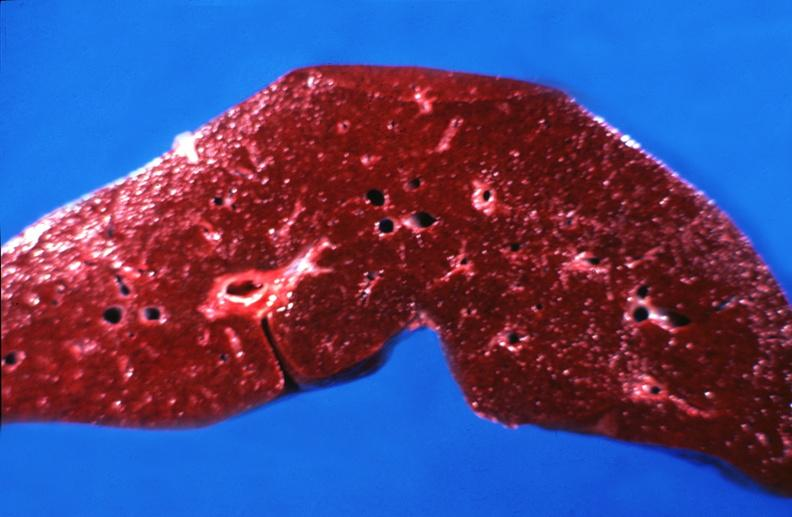what does this image show?
Answer the question using a single word or phrase. Hemochromatosis 